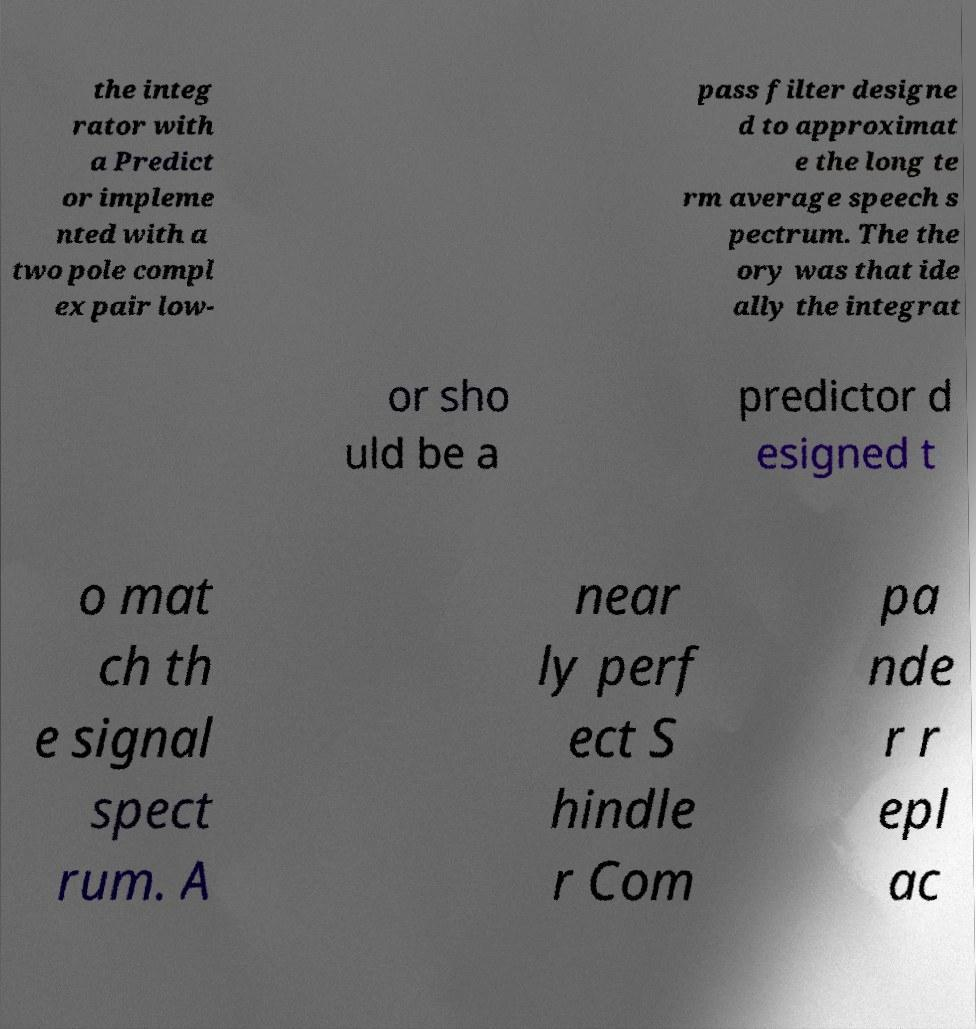There's text embedded in this image that I need extracted. Can you transcribe it verbatim? the integ rator with a Predict or impleme nted with a two pole compl ex pair low- pass filter designe d to approximat e the long te rm average speech s pectrum. The the ory was that ide ally the integrat or sho uld be a predictor d esigned t o mat ch th e signal spect rum. A near ly perf ect S hindle r Com pa nde r r epl ac 